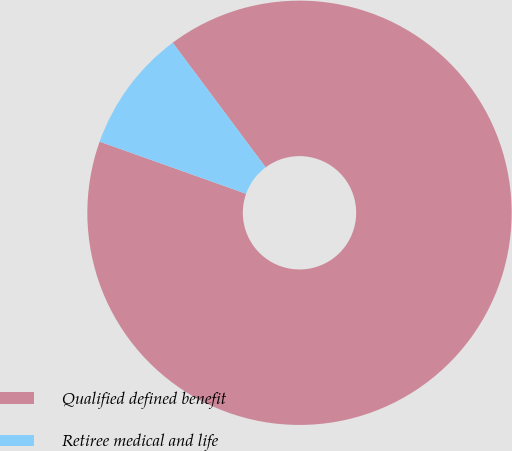Convert chart. <chart><loc_0><loc_0><loc_500><loc_500><pie_chart><fcel>Qualified defined benefit<fcel>Retiree medical and life<nl><fcel>90.64%<fcel>9.36%<nl></chart> 